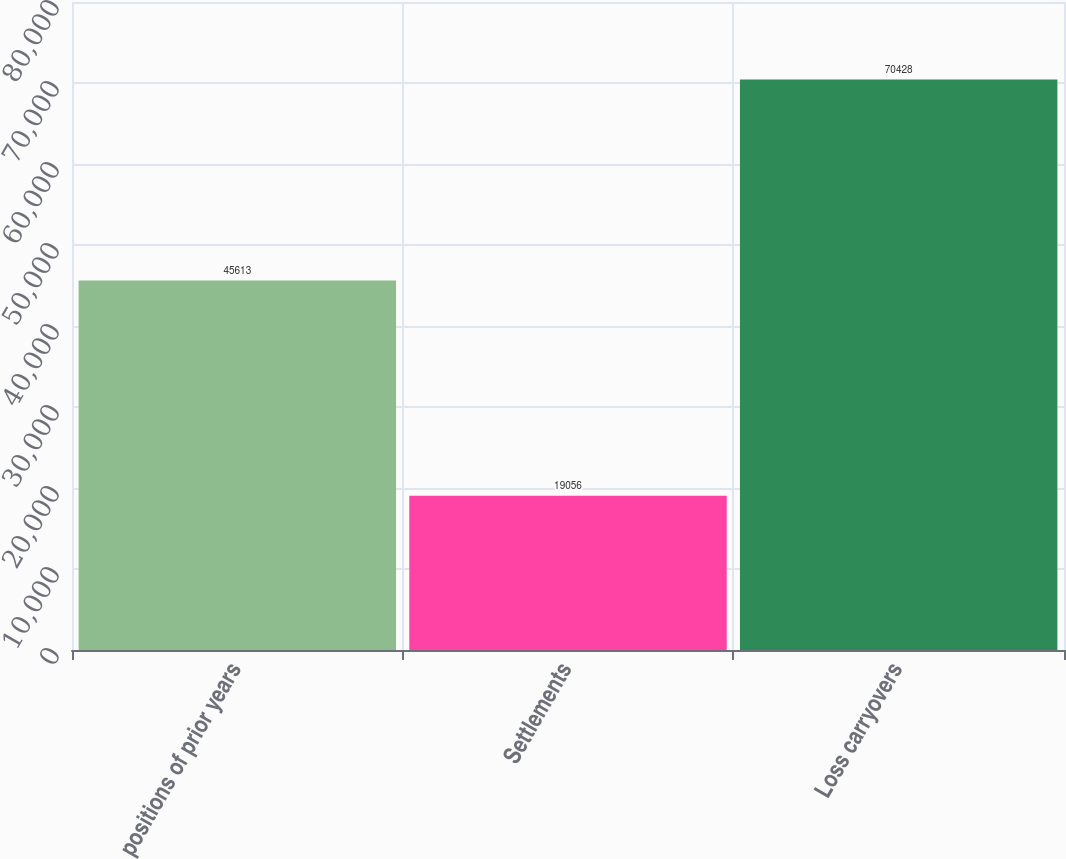Convert chart to OTSL. <chart><loc_0><loc_0><loc_500><loc_500><bar_chart><fcel>positions of prior years<fcel>Settlements<fcel>Loss carryovers<nl><fcel>45613<fcel>19056<fcel>70428<nl></chart> 